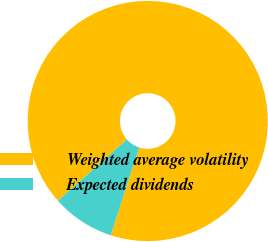Convert chart to OTSL. <chart><loc_0><loc_0><loc_500><loc_500><pie_chart><fcel>Weighted average volatility<fcel>Expected dividends<nl><fcel>91.53%<fcel>8.47%<nl></chart> 